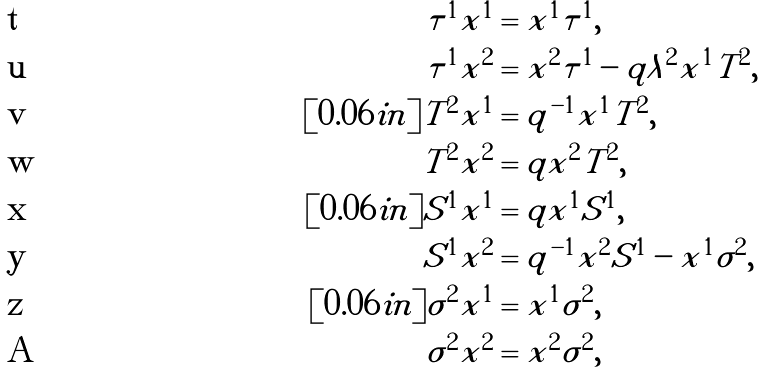Convert formula to latex. <formula><loc_0><loc_0><loc_500><loc_500>\tau ^ { 1 } x ^ { 1 } & = x ^ { 1 } \tau ^ { 1 } , \\ \tau ^ { 1 } x ^ { 2 } & = x ^ { 2 } \tau ^ { 1 } - q \lambda ^ { 2 } x ^ { 1 } T ^ { 2 } , \\ [ 0 . 0 6 i n ] T ^ { 2 } x ^ { 1 } & = q ^ { - 1 } x ^ { 1 } T ^ { 2 } , \\ T ^ { 2 } x ^ { 2 } & = q x ^ { 2 } T ^ { 2 } , \\ [ 0 . 0 6 i n ] S ^ { 1 } x ^ { 1 } & = q x ^ { 1 } S ^ { 1 } , \\ S ^ { 1 } x ^ { 2 } & = q ^ { - 1 } x ^ { 2 } S ^ { 1 } - x ^ { 1 } \sigma ^ { 2 } , \\ [ 0 . 0 6 i n ] \sigma ^ { 2 } x ^ { 1 } & = x ^ { 1 } \sigma ^ { 2 } , \\ \sigma ^ { 2 } x ^ { 2 } & = x ^ { 2 } \sigma ^ { 2 } ,</formula> 